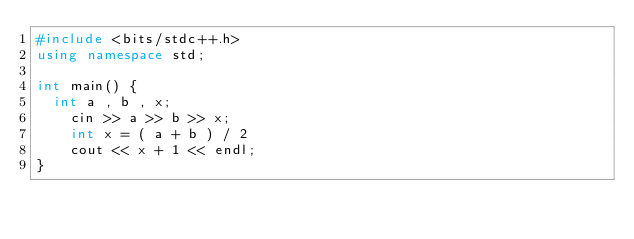<code> <loc_0><loc_0><loc_500><loc_500><_C++_>#include <bits/stdc++.h>
using namespace std;

int main() {
  int a , b , x;
    cin >> a >> b >> x;
  	int x = ( a + b ) / 2
  	cout << x + 1 << endl;
}
</code> 